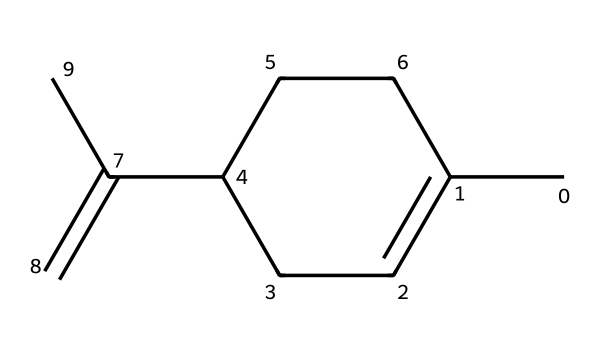What is the molecular formula of limonene? By analyzing the SMILES structure, we can count the number of carbon (C) and hydrogen (H) atoms. The structure contains 10 carbon atoms and 16 hydrogen atoms, leading to the molecular formula C10H16.
Answer: C10H16 How many rings does limonene contain? The SMILES representation indicates that there is a cyclic arrangement of carbon atoms. Specifically, there is one cycle in the structure, which denotes it as a cycloalkane.
Answer: 1 What type of isomerism is present in limonene? The structure of limonene shows that it has a double bond as indicated in the SMILES (C(=C)). This suggests it can exhibit geometric (cis/trans) isomerism around the double bond.
Answer: geometric isomerism What is the degree of unsaturation in limonene? The degree of unsaturation can be calculated based on the molecular formula (C10H16) using the formula (2C + 2 + N - H - X) / 2. Here, we find that the degree of unsaturation is 1, indicating the presence of one ring or double bond.
Answer: 1 Is limonene a saturated or unsaturated compound? The presence of a double bond in the structure indicates that limonene cannot be fully saturated with hydrogen, categorizing it as an unsaturated compound.
Answer: unsaturated What functional group is associated with limonene? The structure of limonene does not explicitly contain a functional group such as alcohols or carboxylic acids but features a double bond and is classified as a terpene. Commonly, it is associated with monoterpenes.
Answer: terpene 